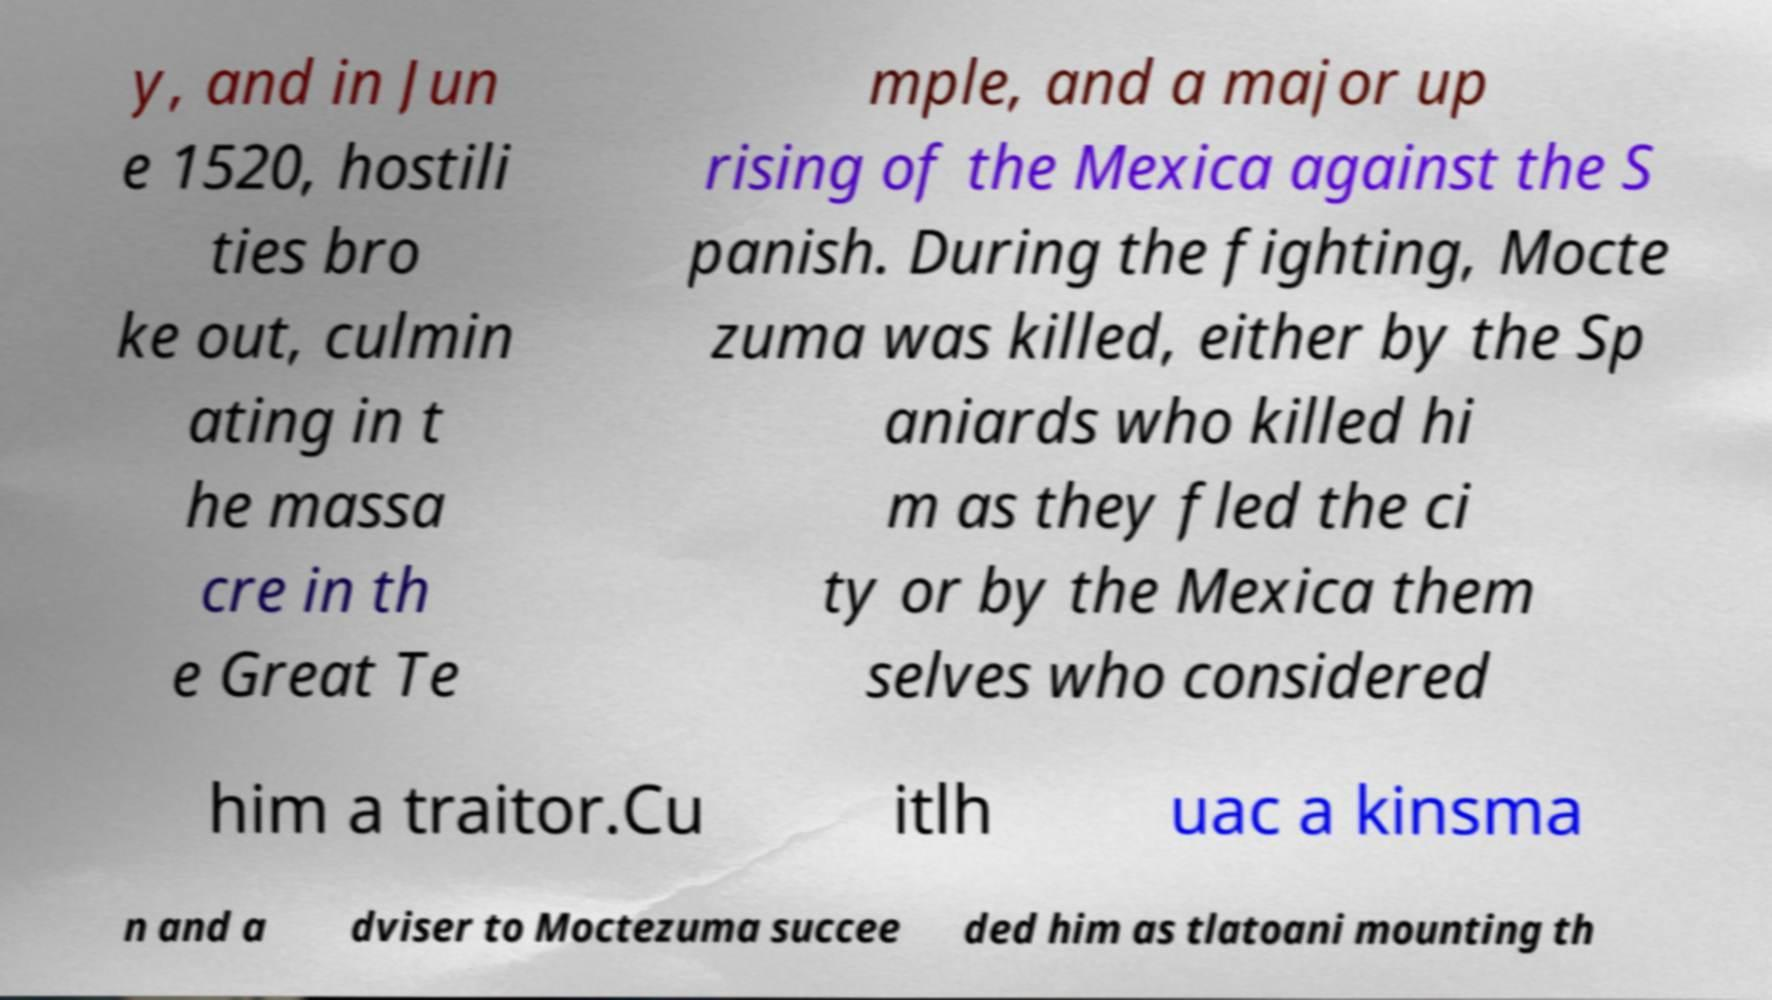Could you assist in decoding the text presented in this image and type it out clearly? y, and in Jun e 1520, hostili ties bro ke out, culmin ating in t he massa cre in th e Great Te mple, and a major up rising of the Mexica against the S panish. During the fighting, Mocte zuma was killed, either by the Sp aniards who killed hi m as they fled the ci ty or by the Mexica them selves who considered him a traitor.Cu itlh uac a kinsma n and a dviser to Moctezuma succee ded him as tlatoani mounting th 